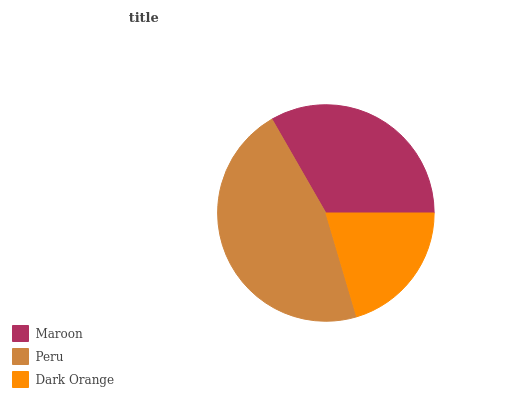Is Dark Orange the minimum?
Answer yes or no. Yes. Is Peru the maximum?
Answer yes or no. Yes. Is Peru the minimum?
Answer yes or no. No. Is Dark Orange the maximum?
Answer yes or no. No. Is Peru greater than Dark Orange?
Answer yes or no. Yes. Is Dark Orange less than Peru?
Answer yes or no. Yes. Is Dark Orange greater than Peru?
Answer yes or no. No. Is Peru less than Dark Orange?
Answer yes or no. No. Is Maroon the high median?
Answer yes or no. Yes. Is Maroon the low median?
Answer yes or no. Yes. Is Peru the high median?
Answer yes or no. No. Is Dark Orange the low median?
Answer yes or no. No. 